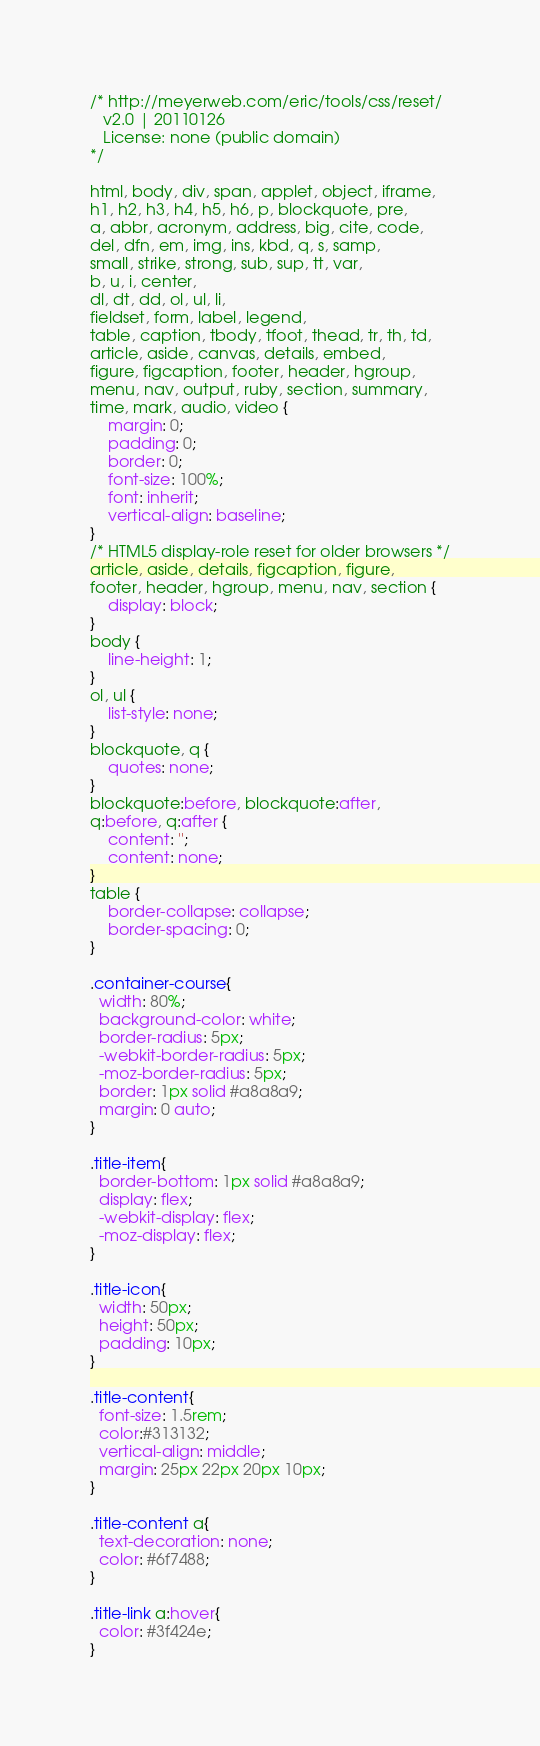Convert code to text. <code><loc_0><loc_0><loc_500><loc_500><_CSS_>/* http://meyerweb.com/eric/tools/css/reset/
   v2.0 | 20110126
   License: none (public domain)
*/

html, body, div, span, applet, object, iframe,
h1, h2, h3, h4, h5, h6, p, blockquote, pre,
a, abbr, acronym, address, big, cite, code,
del, dfn, em, img, ins, kbd, q, s, samp,
small, strike, strong, sub, sup, tt, var,
b, u, i, center,
dl, dt, dd, ol, ul, li,
fieldset, form, label, legend,
table, caption, tbody, tfoot, thead, tr, th, td,
article, aside, canvas, details, embed,
figure, figcaption, footer, header, hgroup,
menu, nav, output, ruby, section, summary,
time, mark, audio, video {
	margin: 0;
	padding: 0;
	border: 0;
	font-size: 100%;
	font: inherit;
	vertical-align: baseline;
}
/* HTML5 display-role reset for older browsers */
article, aside, details, figcaption, figure,
footer, header, hgroup, menu, nav, section {
	display: block;
}
body {
	line-height: 1;
}
ol, ul {
	list-style: none;
}
blockquote, q {
	quotes: none;
}
blockquote:before, blockquote:after,
q:before, q:after {
	content: '';
	content: none;
}
table {
	border-collapse: collapse;
	border-spacing: 0;
}

.container-course{
  width: 80%;
  background-color: white;
  border-radius: 5px;
  -webkit-border-radius: 5px;
  -moz-border-radius: 5px;
  border: 1px solid #a8a8a9;
  margin: 0 auto;
}

.title-item{
  border-bottom: 1px solid #a8a8a9;
  display: flex;
  -webkit-display: flex;
  -moz-display: flex;
}

.title-icon{
  width: 50px;
  height: 50px;
  padding: 10px;
}

.title-content{
  font-size: 1.5rem;
  color:#313132;
  vertical-align: middle;
  margin: 25px 22px 20px 10px;
}

.title-content a{
  text-decoration: none;
  color: #6f7488;
}

.title-link a:hover{
  color: #3f424e;
}
</code> 